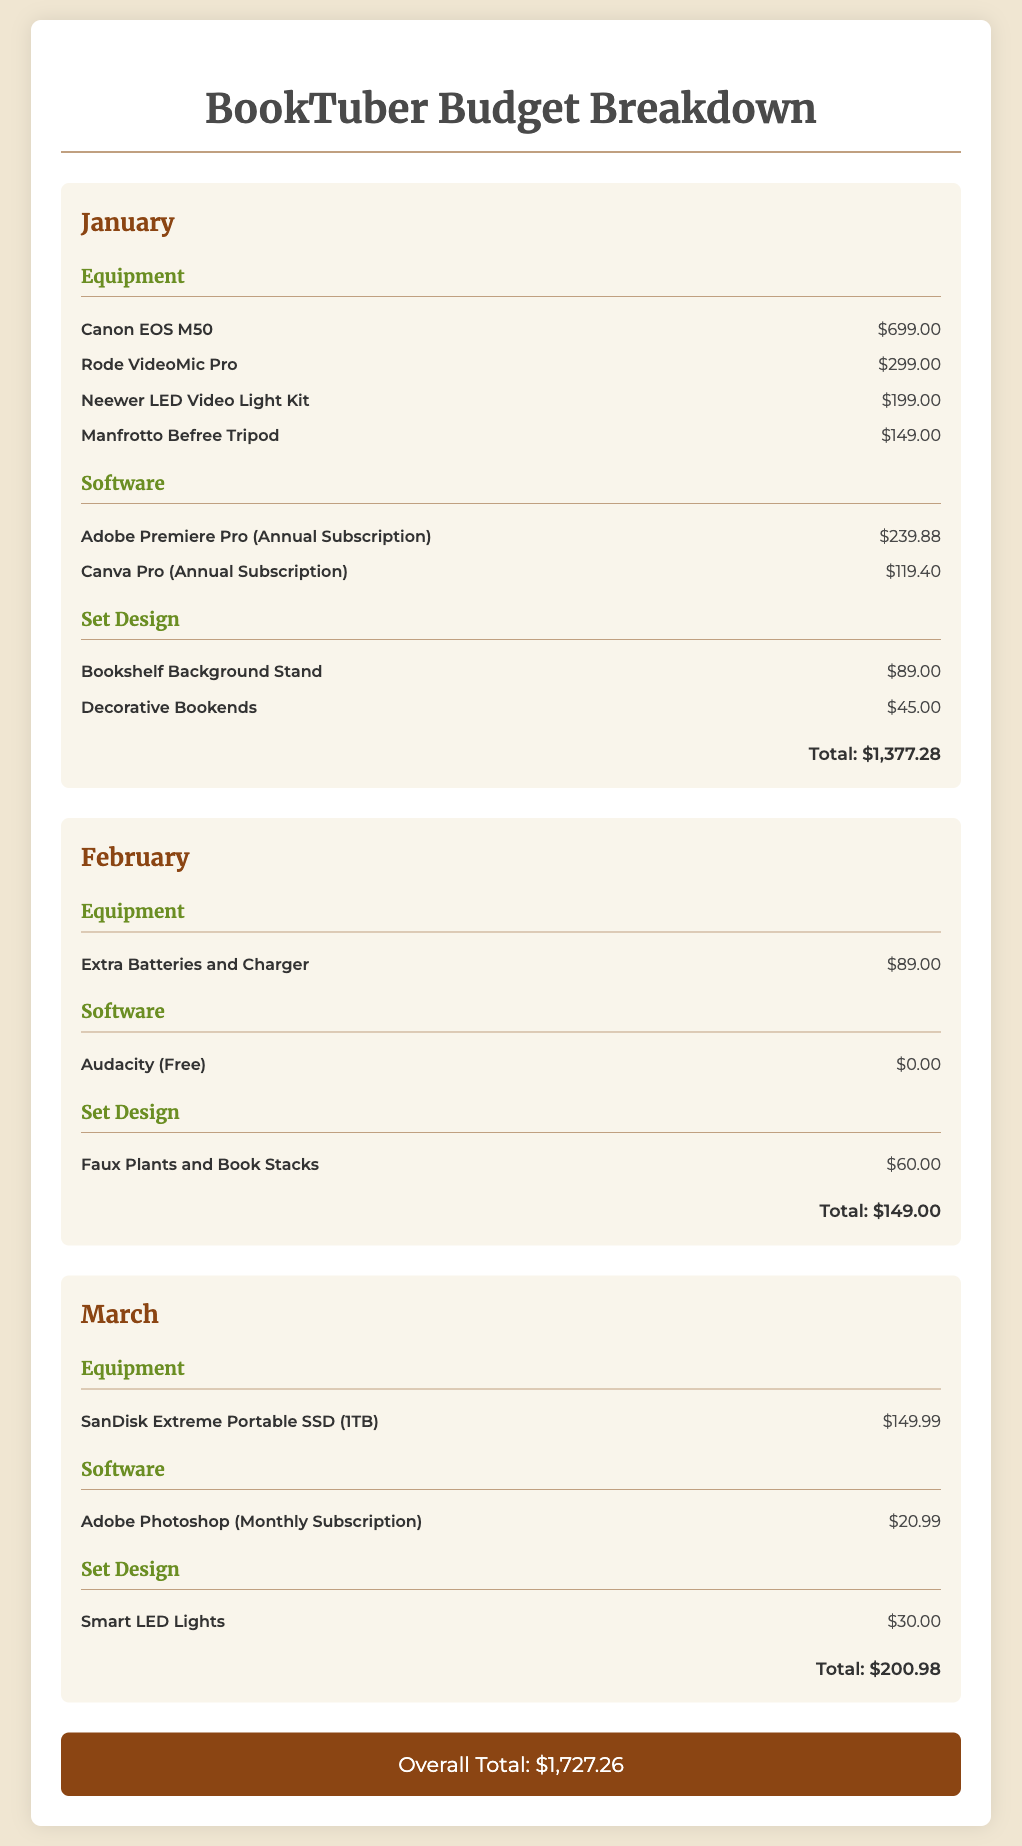What is the total cost for January? The total cost for January is provided at the end of the January section, totaling all equipment, software, and set design expenses.
Answer: $1,377.28 How many equipment items are listed for February? The number of equipment items for February is counted based on the listing under the Equipment category for that month.
Answer: 1 What is the monthly subscription cost for Adobe Photoshop? The monthly subscription cost is found in the Software category for March, specifically listed as the cost for Adobe Photoshop.
Answer: $20.99 What is the cost of the Canon EOS M50? The cost for the Canon EOS M50 is specified in the Equipment category for January, showing the price of this item directly.
Answer: $699.00 What is the total cost for March? The total cost for March summarizes all expenses listed under the categories for that month, providing a total amount.
Answer: $200.98 How much did you spend on set design in February? The spending on set design in February is given in the Set Design category for that month, reflecting the total for items in that section.
Answer: $60.00 What is the grand total for all months combined? The grand total is provided at the bottom of the document, summarizing all monthly expenses across the three months featured.
Answer: $1,727.26 What are the total software costs for January? The total software costs for January are the sum of both software subscriptions listed in the Software category for that month.
Answer: $359.28 